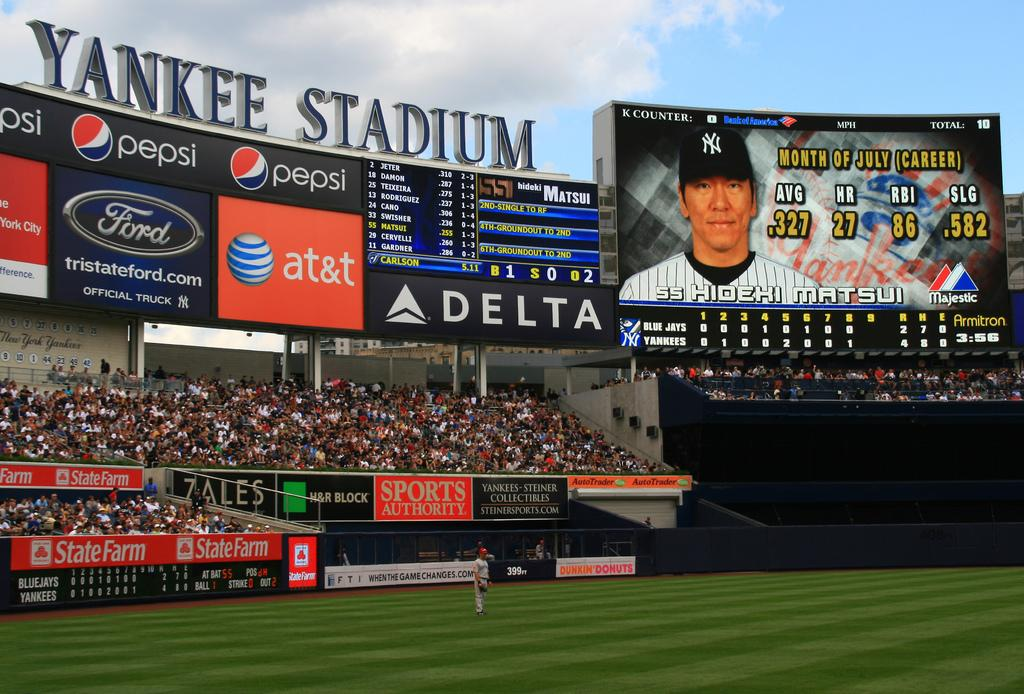<image>
Give a short and clear explanation of the subsequent image. Yankee Stadium showing advertisements for Ford and Pepsi and SS Hidehi Matsui on the big screen. 